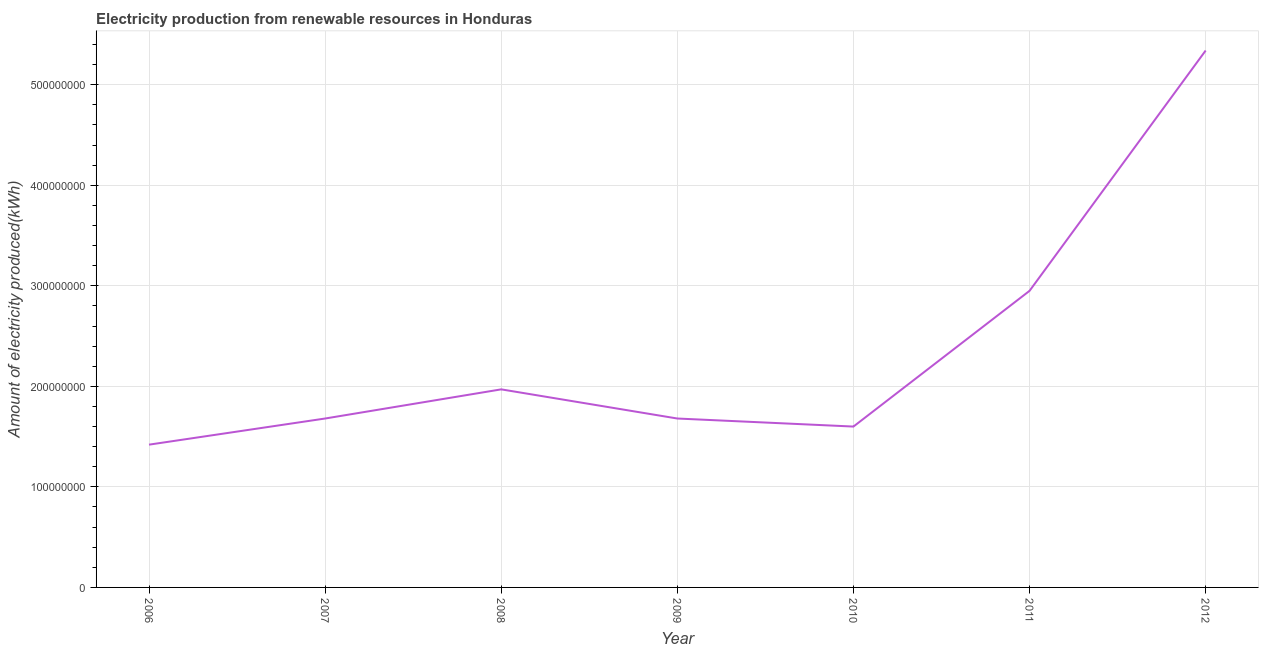What is the amount of electricity produced in 2011?
Ensure brevity in your answer.  2.95e+08. Across all years, what is the maximum amount of electricity produced?
Provide a succinct answer. 5.34e+08. Across all years, what is the minimum amount of electricity produced?
Make the answer very short. 1.42e+08. What is the sum of the amount of electricity produced?
Make the answer very short. 1.66e+09. What is the difference between the amount of electricity produced in 2007 and 2010?
Provide a succinct answer. 8.00e+06. What is the average amount of electricity produced per year?
Keep it short and to the point. 2.38e+08. What is the median amount of electricity produced?
Your response must be concise. 1.68e+08. Do a majority of the years between 2010 and 2011 (inclusive) have amount of electricity produced greater than 360000000 kWh?
Make the answer very short. No. What is the ratio of the amount of electricity produced in 2007 to that in 2009?
Ensure brevity in your answer.  1. Is the difference between the amount of electricity produced in 2010 and 2011 greater than the difference between any two years?
Give a very brief answer. No. What is the difference between the highest and the second highest amount of electricity produced?
Your answer should be very brief. 2.39e+08. What is the difference between the highest and the lowest amount of electricity produced?
Offer a very short reply. 3.92e+08. In how many years, is the amount of electricity produced greater than the average amount of electricity produced taken over all years?
Keep it short and to the point. 2. How many lines are there?
Ensure brevity in your answer.  1. How many years are there in the graph?
Offer a very short reply. 7. Are the values on the major ticks of Y-axis written in scientific E-notation?
Give a very brief answer. No. What is the title of the graph?
Provide a short and direct response. Electricity production from renewable resources in Honduras. What is the label or title of the X-axis?
Ensure brevity in your answer.  Year. What is the label or title of the Y-axis?
Provide a short and direct response. Amount of electricity produced(kWh). What is the Amount of electricity produced(kWh) in 2006?
Your answer should be compact. 1.42e+08. What is the Amount of electricity produced(kWh) in 2007?
Ensure brevity in your answer.  1.68e+08. What is the Amount of electricity produced(kWh) of 2008?
Keep it short and to the point. 1.97e+08. What is the Amount of electricity produced(kWh) in 2009?
Give a very brief answer. 1.68e+08. What is the Amount of electricity produced(kWh) in 2010?
Provide a succinct answer. 1.60e+08. What is the Amount of electricity produced(kWh) in 2011?
Provide a succinct answer. 2.95e+08. What is the Amount of electricity produced(kWh) in 2012?
Keep it short and to the point. 5.34e+08. What is the difference between the Amount of electricity produced(kWh) in 2006 and 2007?
Keep it short and to the point. -2.60e+07. What is the difference between the Amount of electricity produced(kWh) in 2006 and 2008?
Provide a succinct answer. -5.50e+07. What is the difference between the Amount of electricity produced(kWh) in 2006 and 2009?
Make the answer very short. -2.60e+07. What is the difference between the Amount of electricity produced(kWh) in 2006 and 2010?
Offer a terse response. -1.80e+07. What is the difference between the Amount of electricity produced(kWh) in 2006 and 2011?
Ensure brevity in your answer.  -1.53e+08. What is the difference between the Amount of electricity produced(kWh) in 2006 and 2012?
Your answer should be compact. -3.92e+08. What is the difference between the Amount of electricity produced(kWh) in 2007 and 2008?
Your answer should be compact. -2.90e+07. What is the difference between the Amount of electricity produced(kWh) in 2007 and 2010?
Offer a terse response. 8.00e+06. What is the difference between the Amount of electricity produced(kWh) in 2007 and 2011?
Your response must be concise. -1.27e+08. What is the difference between the Amount of electricity produced(kWh) in 2007 and 2012?
Ensure brevity in your answer.  -3.66e+08. What is the difference between the Amount of electricity produced(kWh) in 2008 and 2009?
Your answer should be very brief. 2.90e+07. What is the difference between the Amount of electricity produced(kWh) in 2008 and 2010?
Give a very brief answer. 3.70e+07. What is the difference between the Amount of electricity produced(kWh) in 2008 and 2011?
Your answer should be compact. -9.80e+07. What is the difference between the Amount of electricity produced(kWh) in 2008 and 2012?
Offer a very short reply. -3.37e+08. What is the difference between the Amount of electricity produced(kWh) in 2009 and 2011?
Make the answer very short. -1.27e+08. What is the difference between the Amount of electricity produced(kWh) in 2009 and 2012?
Your response must be concise. -3.66e+08. What is the difference between the Amount of electricity produced(kWh) in 2010 and 2011?
Your answer should be very brief. -1.35e+08. What is the difference between the Amount of electricity produced(kWh) in 2010 and 2012?
Provide a short and direct response. -3.74e+08. What is the difference between the Amount of electricity produced(kWh) in 2011 and 2012?
Make the answer very short. -2.39e+08. What is the ratio of the Amount of electricity produced(kWh) in 2006 to that in 2007?
Give a very brief answer. 0.84. What is the ratio of the Amount of electricity produced(kWh) in 2006 to that in 2008?
Provide a short and direct response. 0.72. What is the ratio of the Amount of electricity produced(kWh) in 2006 to that in 2009?
Keep it short and to the point. 0.84. What is the ratio of the Amount of electricity produced(kWh) in 2006 to that in 2010?
Provide a succinct answer. 0.89. What is the ratio of the Amount of electricity produced(kWh) in 2006 to that in 2011?
Make the answer very short. 0.48. What is the ratio of the Amount of electricity produced(kWh) in 2006 to that in 2012?
Your answer should be compact. 0.27. What is the ratio of the Amount of electricity produced(kWh) in 2007 to that in 2008?
Your answer should be compact. 0.85. What is the ratio of the Amount of electricity produced(kWh) in 2007 to that in 2011?
Your answer should be very brief. 0.57. What is the ratio of the Amount of electricity produced(kWh) in 2007 to that in 2012?
Keep it short and to the point. 0.32. What is the ratio of the Amount of electricity produced(kWh) in 2008 to that in 2009?
Your answer should be very brief. 1.17. What is the ratio of the Amount of electricity produced(kWh) in 2008 to that in 2010?
Ensure brevity in your answer.  1.23. What is the ratio of the Amount of electricity produced(kWh) in 2008 to that in 2011?
Your answer should be very brief. 0.67. What is the ratio of the Amount of electricity produced(kWh) in 2008 to that in 2012?
Offer a terse response. 0.37. What is the ratio of the Amount of electricity produced(kWh) in 2009 to that in 2010?
Make the answer very short. 1.05. What is the ratio of the Amount of electricity produced(kWh) in 2009 to that in 2011?
Give a very brief answer. 0.57. What is the ratio of the Amount of electricity produced(kWh) in 2009 to that in 2012?
Provide a succinct answer. 0.32. What is the ratio of the Amount of electricity produced(kWh) in 2010 to that in 2011?
Provide a short and direct response. 0.54. What is the ratio of the Amount of electricity produced(kWh) in 2010 to that in 2012?
Your answer should be compact. 0.3. What is the ratio of the Amount of electricity produced(kWh) in 2011 to that in 2012?
Your response must be concise. 0.55. 